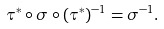Convert formula to latex. <formula><loc_0><loc_0><loc_500><loc_500>\tau ^ { * } \circ \sigma \circ ( \tau ^ { * } ) ^ { - 1 } = \sigma ^ { - 1 } .</formula> 